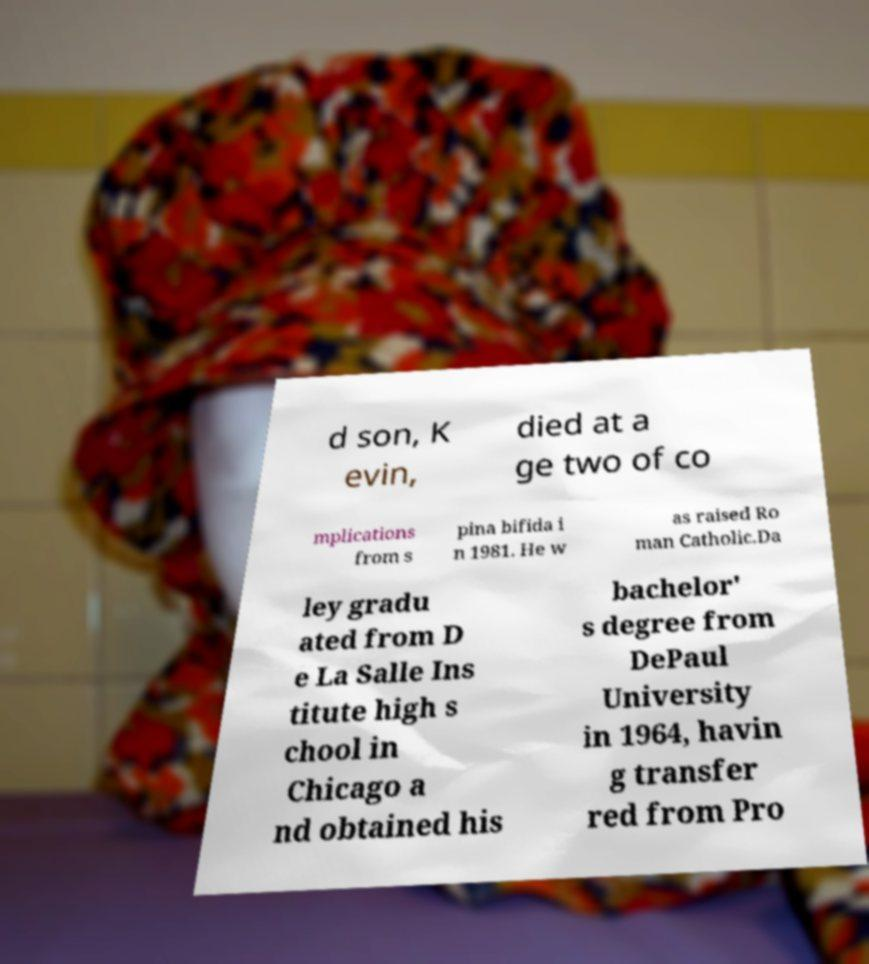Can you accurately transcribe the text from the provided image for me? d son, K evin, died at a ge two of co mplications from s pina bifida i n 1981. He w as raised Ro man Catholic.Da ley gradu ated from D e La Salle Ins titute high s chool in Chicago a nd obtained his bachelor' s degree from DePaul University in 1964, havin g transfer red from Pro 